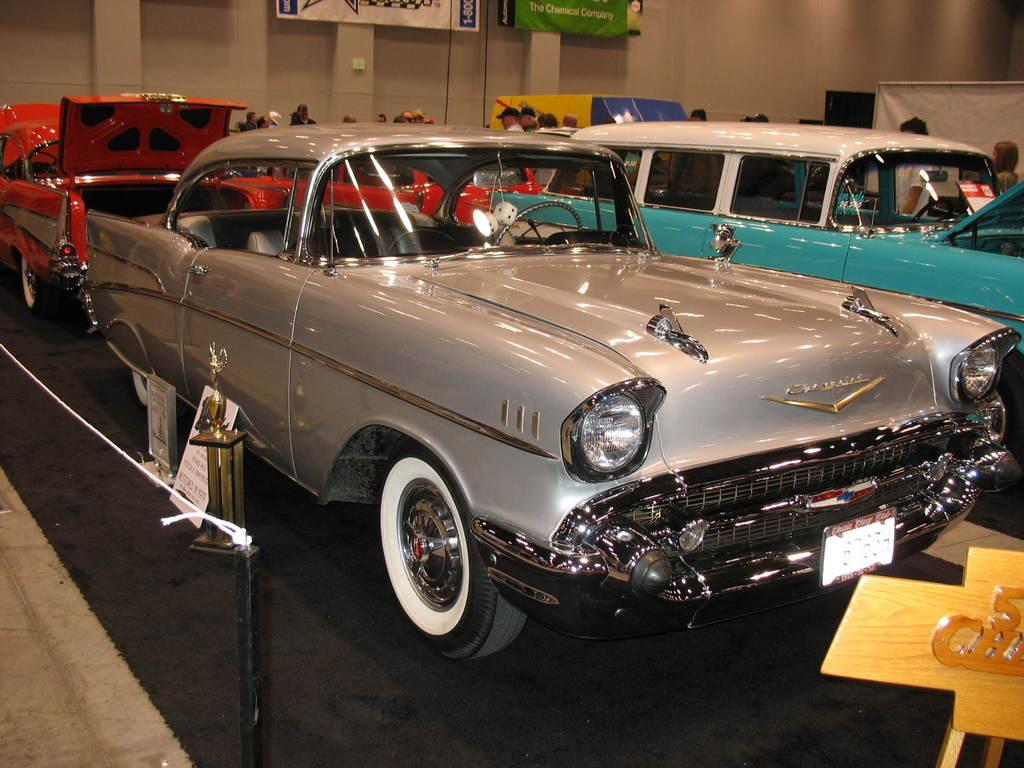What type of vehicles can be seen in the image? There are cars in the image. What is located on the right side of the image? There is a board on the right side of the image. What is on the left side of the image? There is a rope fence on the left side of the image. Can you describe the people in the image? People are standing in the image. What else can be seen in the image besides the cars, board, rope fence, and people? There are banners in the image. What type of yarn is being used to comb the people's hair in the image? There is no yarn or combing activity present in the image. What expression do the people have on their faces in the image? The provided facts do not mention the people's facial expressions, so we cannot determine if they are smiling or not. 